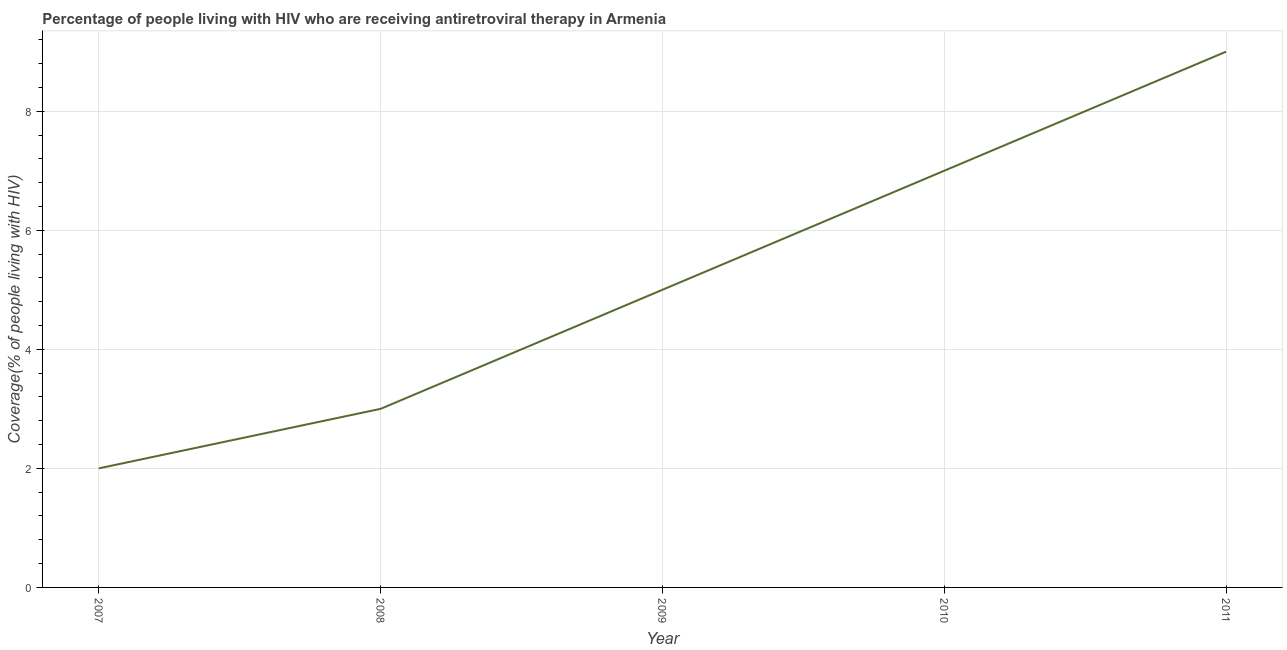What is the antiretroviral therapy coverage in 2009?
Offer a terse response. 5. Across all years, what is the maximum antiretroviral therapy coverage?
Offer a terse response. 9. Across all years, what is the minimum antiretroviral therapy coverage?
Provide a succinct answer. 2. In which year was the antiretroviral therapy coverage maximum?
Your answer should be compact. 2011. What is the sum of the antiretroviral therapy coverage?
Offer a terse response. 26. What is the difference between the antiretroviral therapy coverage in 2007 and 2010?
Offer a terse response. -5. What is the average antiretroviral therapy coverage per year?
Offer a very short reply. 5.2. In how many years, is the antiretroviral therapy coverage greater than 8.4 %?
Keep it short and to the point. 1. Do a majority of the years between 2010 and 2008 (inclusive) have antiretroviral therapy coverage greater than 4.8 %?
Your response must be concise. No. What is the ratio of the antiretroviral therapy coverage in 2007 to that in 2011?
Keep it short and to the point. 0.22. Is the antiretroviral therapy coverage in 2008 less than that in 2009?
Your response must be concise. Yes. Is the difference between the antiretroviral therapy coverage in 2008 and 2011 greater than the difference between any two years?
Give a very brief answer. No. Is the sum of the antiretroviral therapy coverage in 2007 and 2008 greater than the maximum antiretroviral therapy coverage across all years?
Your response must be concise. No. What is the difference between the highest and the lowest antiretroviral therapy coverage?
Your answer should be compact. 7. How many years are there in the graph?
Ensure brevity in your answer.  5. What is the difference between two consecutive major ticks on the Y-axis?
Offer a very short reply. 2. What is the title of the graph?
Keep it short and to the point. Percentage of people living with HIV who are receiving antiretroviral therapy in Armenia. What is the label or title of the X-axis?
Offer a very short reply. Year. What is the label or title of the Y-axis?
Provide a short and direct response. Coverage(% of people living with HIV). What is the Coverage(% of people living with HIV) of 2007?
Provide a succinct answer. 2. What is the Coverage(% of people living with HIV) of 2008?
Make the answer very short. 3. What is the Coverage(% of people living with HIV) of 2009?
Your answer should be very brief. 5. What is the Coverage(% of people living with HIV) of 2011?
Your answer should be compact. 9. What is the difference between the Coverage(% of people living with HIV) in 2007 and 2008?
Keep it short and to the point. -1. What is the difference between the Coverage(% of people living with HIV) in 2007 and 2009?
Offer a very short reply. -3. What is the difference between the Coverage(% of people living with HIV) in 2007 and 2010?
Provide a short and direct response. -5. What is the difference between the Coverage(% of people living with HIV) in 2009 and 2011?
Provide a short and direct response. -4. What is the ratio of the Coverage(% of people living with HIV) in 2007 to that in 2008?
Give a very brief answer. 0.67. What is the ratio of the Coverage(% of people living with HIV) in 2007 to that in 2009?
Offer a terse response. 0.4. What is the ratio of the Coverage(% of people living with HIV) in 2007 to that in 2010?
Offer a terse response. 0.29. What is the ratio of the Coverage(% of people living with HIV) in 2007 to that in 2011?
Offer a very short reply. 0.22. What is the ratio of the Coverage(% of people living with HIV) in 2008 to that in 2009?
Provide a succinct answer. 0.6. What is the ratio of the Coverage(% of people living with HIV) in 2008 to that in 2010?
Provide a succinct answer. 0.43. What is the ratio of the Coverage(% of people living with HIV) in 2008 to that in 2011?
Your response must be concise. 0.33. What is the ratio of the Coverage(% of people living with HIV) in 2009 to that in 2010?
Make the answer very short. 0.71. What is the ratio of the Coverage(% of people living with HIV) in 2009 to that in 2011?
Keep it short and to the point. 0.56. What is the ratio of the Coverage(% of people living with HIV) in 2010 to that in 2011?
Provide a succinct answer. 0.78. 